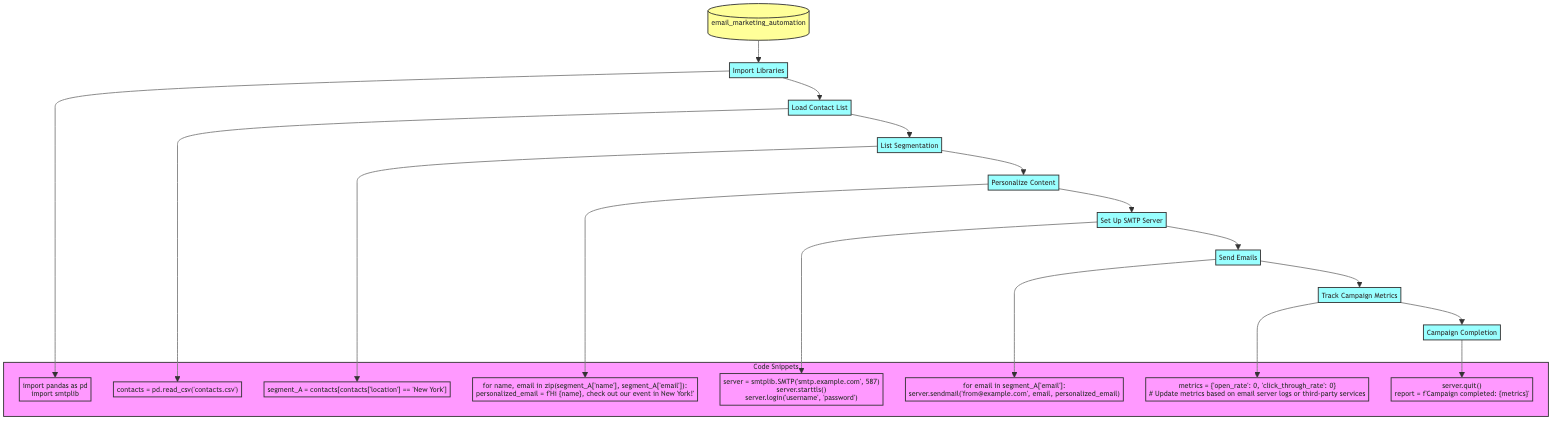What is the first step in the email marketing automation process? The first step in the flowchart is "Import Libraries." This is indicated by the first node labeled B, which leads into the process.
Answer: Import Libraries How many steps are there in the email marketing automation process? By counting the separate nodes in the diagram, we find there are a total of 8 steps, from "Import Libraries" to "Campaign Completion."
Answer: 8 What step comes after "Set Up SMTP Server"? The next step after "Set Up SMTP Server," labeled F in the diagram, is "Send Emails," which is represented by the node labeled G.
Answer: Send Emails What segment is created during the list segmentation step? The segment created during the "List Segmentation" step is labeled as "segment_A," which consists of contacts based on location criteria.
Answer: segment_A Which step involves customizing email content? The step that involves customizing email content is "Personalize Content." This step is indicated by node E, which follows the "List Segmentation" step.
Answer: Personalize Content What is the purpose of the "Track Campaign Metrics" step? The purpose of the "Track Campaign Metrics" step is to monitor key metrics such as open rate and click-through rate, as stated in the functionality described in the diagram.
Answer: Monitor metrics What do we do at the final step of the process? At the final step, "Campaign Completion," we close the SMTP server connection and generate a report. This is reflected in the last node labeled I.
Answer: Generate a report How is the contact list loaded into the process? The contact list is loaded using a CSV file, with the specific command shown in node C: "contacts = pd.read_csv('contacts.csv')."
Answer: CSV file What does the "Send Emails" step specifically do? The "Send Emails" step sends personalized emails to each contact in the segmented list, as indicated in its functionality in the flowchart.
Answer: Sends personalized emails 